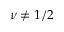<formula> <loc_0><loc_0><loc_500><loc_500>\nu \neq 1 / 2</formula> 